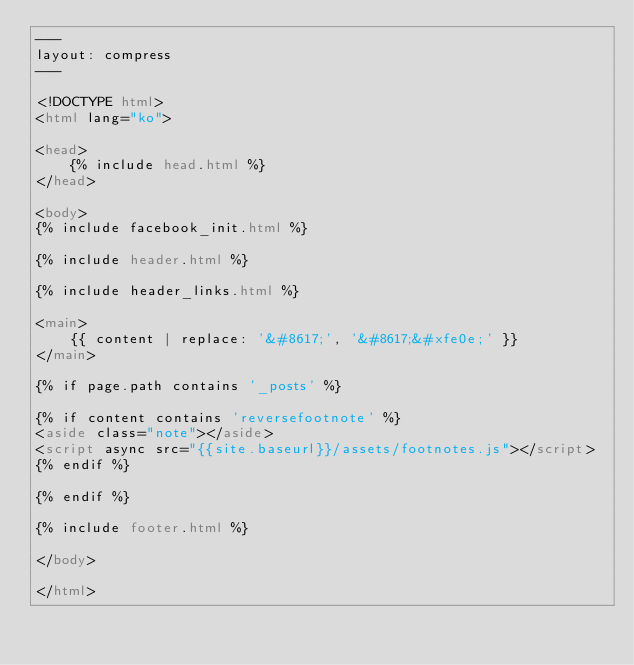Convert code to text. <code><loc_0><loc_0><loc_500><loc_500><_HTML_>---
layout: compress
---

<!DOCTYPE html>
<html lang="ko">

<head>
    {% include head.html %}
</head>

<body>
{% include facebook_init.html %}

{% include header.html %}

{% include header_links.html %}

<main>
    {{ content | replace: '&#8617;', '&#8617;&#xfe0e;' }}
</main>

{% if page.path contains '_posts' %}

{% if content contains 'reversefootnote' %}
<aside class="note"></aside>
<script async src="{{site.baseurl}}/assets/footnotes.js"></script>
{% endif %}

{% endif %}

{% include footer.html %}

</body>

</html>
</code> 